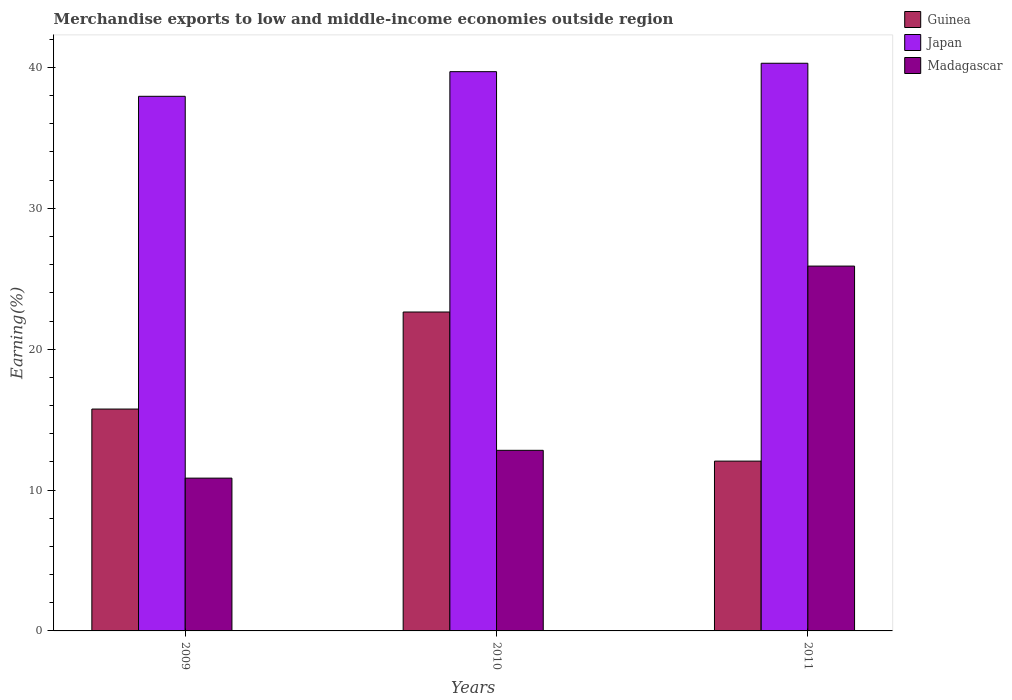Are the number of bars per tick equal to the number of legend labels?
Make the answer very short. Yes. Are the number of bars on each tick of the X-axis equal?
Make the answer very short. Yes. What is the label of the 1st group of bars from the left?
Keep it short and to the point. 2009. What is the percentage of amount earned from merchandise exports in Madagascar in 2011?
Provide a succinct answer. 25.9. Across all years, what is the maximum percentage of amount earned from merchandise exports in Madagascar?
Make the answer very short. 25.9. Across all years, what is the minimum percentage of amount earned from merchandise exports in Madagascar?
Provide a succinct answer. 10.85. In which year was the percentage of amount earned from merchandise exports in Japan maximum?
Your answer should be very brief. 2011. What is the total percentage of amount earned from merchandise exports in Madagascar in the graph?
Your response must be concise. 49.57. What is the difference between the percentage of amount earned from merchandise exports in Japan in 2009 and that in 2011?
Give a very brief answer. -2.35. What is the difference between the percentage of amount earned from merchandise exports in Madagascar in 2011 and the percentage of amount earned from merchandise exports in Guinea in 2010?
Provide a succinct answer. 3.26. What is the average percentage of amount earned from merchandise exports in Guinea per year?
Offer a terse response. 16.81. In the year 2011, what is the difference between the percentage of amount earned from merchandise exports in Guinea and percentage of amount earned from merchandise exports in Madagascar?
Give a very brief answer. -13.85. In how many years, is the percentage of amount earned from merchandise exports in Guinea greater than 36 %?
Make the answer very short. 0. What is the ratio of the percentage of amount earned from merchandise exports in Japan in 2009 to that in 2010?
Make the answer very short. 0.96. Is the percentage of amount earned from merchandise exports in Guinea in 2010 less than that in 2011?
Offer a very short reply. No. Is the difference between the percentage of amount earned from merchandise exports in Guinea in 2009 and 2010 greater than the difference between the percentage of amount earned from merchandise exports in Madagascar in 2009 and 2010?
Your answer should be very brief. No. What is the difference between the highest and the second highest percentage of amount earned from merchandise exports in Guinea?
Your answer should be compact. 6.89. What is the difference between the highest and the lowest percentage of amount earned from merchandise exports in Guinea?
Offer a terse response. 10.58. What does the 3rd bar from the right in 2010 represents?
Make the answer very short. Guinea. Is it the case that in every year, the sum of the percentage of amount earned from merchandise exports in Madagascar and percentage of amount earned from merchandise exports in Guinea is greater than the percentage of amount earned from merchandise exports in Japan?
Make the answer very short. No. What is the difference between two consecutive major ticks on the Y-axis?
Ensure brevity in your answer.  10. Does the graph contain any zero values?
Offer a very short reply. No. Where does the legend appear in the graph?
Give a very brief answer. Top right. How many legend labels are there?
Your response must be concise. 3. How are the legend labels stacked?
Your response must be concise. Vertical. What is the title of the graph?
Provide a succinct answer. Merchandise exports to low and middle-income economies outside region. Does "Sudan" appear as one of the legend labels in the graph?
Your answer should be compact. No. What is the label or title of the X-axis?
Offer a terse response. Years. What is the label or title of the Y-axis?
Offer a terse response. Earning(%). What is the Earning(%) in Guinea in 2009?
Give a very brief answer. 15.75. What is the Earning(%) of Japan in 2009?
Your answer should be compact. 37.95. What is the Earning(%) of Madagascar in 2009?
Keep it short and to the point. 10.85. What is the Earning(%) in Guinea in 2010?
Keep it short and to the point. 22.64. What is the Earning(%) of Japan in 2010?
Ensure brevity in your answer.  39.7. What is the Earning(%) in Madagascar in 2010?
Provide a succinct answer. 12.82. What is the Earning(%) of Guinea in 2011?
Give a very brief answer. 12.05. What is the Earning(%) of Japan in 2011?
Your answer should be very brief. 40.3. What is the Earning(%) in Madagascar in 2011?
Make the answer very short. 25.9. Across all years, what is the maximum Earning(%) of Guinea?
Your answer should be compact. 22.64. Across all years, what is the maximum Earning(%) of Japan?
Your answer should be compact. 40.3. Across all years, what is the maximum Earning(%) in Madagascar?
Your response must be concise. 25.9. Across all years, what is the minimum Earning(%) in Guinea?
Provide a short and direct response. 12.05. Across all years, what is the minimum Earning(%) of Japan?
Your response must be concise. 37.95. Across all years, what is the minimum Earning(%) in Madagascar?
Ensure brevity in your answer.  10.85. What is the total Earning(%) of Guinea in the graph?
Your answer should be compact. 50.44. What is the total Earning(%) in Japan in the graph?
Offer a terse response. 117.95. What is the total Earning(%) of Madagascar in the graph?
Keep it short and to the point. 49.57. What is the difference between the Earning(%) of Guinea in 2009 and that in 2010?
Provide a succinct answer. -6.89. What is the difference between the Earning(%) of Japan in 2009 and that in 2010?
Ensure brevity in your answer.  -1.75. What is the difference between the Earning(%) of Madagascar in 2009 and that in 2010?
Give a very brief answer. -1.98. What is the difference between the Earning(%) in Guinea in 2009 and that in 2011?
Provide a short and direct response. 3.7. What is the difference between the Earning(%) in Japan in 2009 and that in 2011?
Keep it short and to the point. -2.35. What is the difference between the Earning(%) of Madagascar in 2009 and that in 2011?
Offer a very short reply. -15.05. What is the difference between the Earning(%) of Guinea in 2010 and that in 2011?
Provide a short and direct response. 10.58. What is the difference between the Earning(%) of Japan in 2010 and that in 2011?
Make the answer very short. -0.6. What is the difference between the Earning(%) of Madagascar in 2010 and that in 2011?
Your answer should be compact. -13.08. What is the difference between the Earning(%) of Guinea in 2009 and the Earning(%) of Japan in 2010?
Give a very brief answer. -23.95. What is the difference between the Earning(%) in Guinea in 2009 and the Earning(%) in Madagascar in 2010?
Make the answer very short. 2.93. What is the difference between the Earning(%) in Japan in 2009 and the Earning(%) in Madagascar in 2010?
Provide a short and direct response. 25.13. What is the difference between the Earning(%) in Guinea in 2009 and the Earning(%) in Japan in 2011?
Keep it short and to the point. -24.55. What is the difference between the Earning(%) of Guinea in 2009 and the Earning(%) of Madagascar in 2011?
Your response must be concise. -10.15. What is the difference between the Earning(%) in Japan in 2009 and the Earning(%) in Madagascar in 2011?
Offer a terse response. 12.05. What is the difference between the Earning(%) in Guinea in 2010 and the Earning(%) in Japan in 2011?
Your answer should be compact. -17.66. What is the difference between the Earning(%) in Guinea in 2010 and the Earning(%) in Madagascar in 2011?
Make the answer very short. -3.26. What is the difference between the Earning(%) in Japan in 2010 and the Earning(%) in Madagascar in 2011?
Offer a terse response. 13.8. What is the average Earning(%) of Guinea per year?
Provide a short and direct response. 16.81. What is the average Earning(%) of Japan per year?
Give a very brief answer. 39.32. What is the average Earning(%) of Madagascar per year?
Provide a short and direct response. 16.52. In the year 2009, what is the difference between the Earning(%) in Guinea and Earning(%) in Japan?
Offer a very short reply. -22.2. In the year 2009, what is the difference between the Earning(%) of Guinea and Earning(%) of Madagascar?
Make the answer very short. 4.9. In the year 2009, what is the difference between the Earning(%) of Japan and Earning(%) of Madagascar?
Ensure brevity in your answer.  27.11. In the year 2010, what is the difference between the Earning(%) in Guinea and Earning(%) in Japan?
Provide a succinct answer. -17.06. In the year 2010, what is the difference between the Earning(%) of Guinea and Earning(%) of Madagascar?
Offer a terse response. 9.82. In the year 2010, what is the difference between the Earning(%) in Japan and Earning(%) in Madagascar?
Offer a terse response. 26.88. In the year 2011, what is the difference between the Earning(%) in Guinea and Earning(%) in Japan?
Make the answer very short. -28.24. In the year 2011, what is the difference between the Earning(%) of Guinea and Earning(%) of Madagascar?
Your response must be concise. -13.85. In the year 2011, what is the difference between the Earning(%) in Japan and Earning(%) in Madagascar?
Provide a short and direct response. 14.4. What is the ratio of the Earning(%) in Guinea in 2009 to that in 2010?
Offer a very short reply. 0.7. What is the ratio of the Earning(%) in Japan in 2009 to that in 2010?
Your answer should be compact. 0.96. What is the ratio of the Earning(%) in Madagascar in 2009 to that in 2010?
Keep it short and to the point. 0.85. What is the ratio of the Earning(%) of Guinea in 2009 to that in 2011?
Your answer should be compact. 1.31. What is the ratio of the Earning(%) in Japan in 2009 to that in 2011?
Provide a short and direct response. 0.94. What is the ratio of the Earning(%) in Madagascar in 2009 to that in 2011?
Offer a very short reply. 0.42. What is the ratio of the Earning(%) of Guinea in 2010 to that in 2011?
Ensure brevity in your answer.  1.88. What is the ratio of the Earning(%) in Japan in 2010 to that in 2011?
Make the answer very short. 0.99. What is the ratio of the Earning(%) of Madagascar in 2010 to that in 2011?
Offer a very short reply. 0.49. What is the difference between the highest and the second highest Earning(%) of Guinea?
Give a very brief answer. 6.89. What is the difference between the highest and the second highest Earning(%) in Japan?
Provide a succinct answer. 0.6. What is the difference between the highest and the second highest Earning(%) in Madagascar?
Make the answer very short. 13.08. What is the difference between the highest and the lowest Earning(%) of Guinea?
Keep it short and to the point. 10.58. What is the difference between the highest and the lowest Earning(%) of Japan?
Give a very brief answer. 2.35. What is the difference between the highest and the lowest Earning(%) in Madagascar?
Your answer should be very brief. 15.05. 